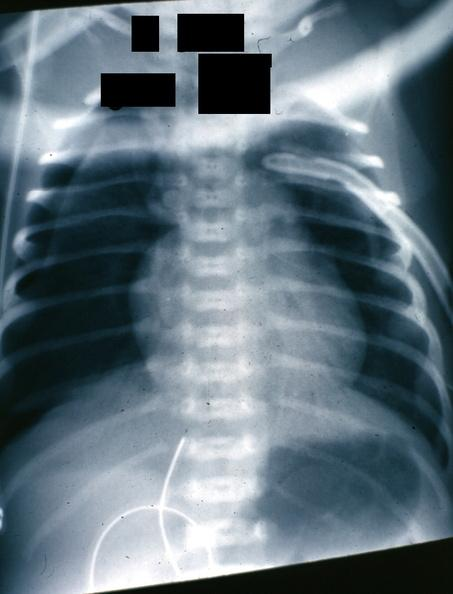what does this image show?
Answer the question using a single word or phrase. X-ray nicely shown pneumothorax in infant 